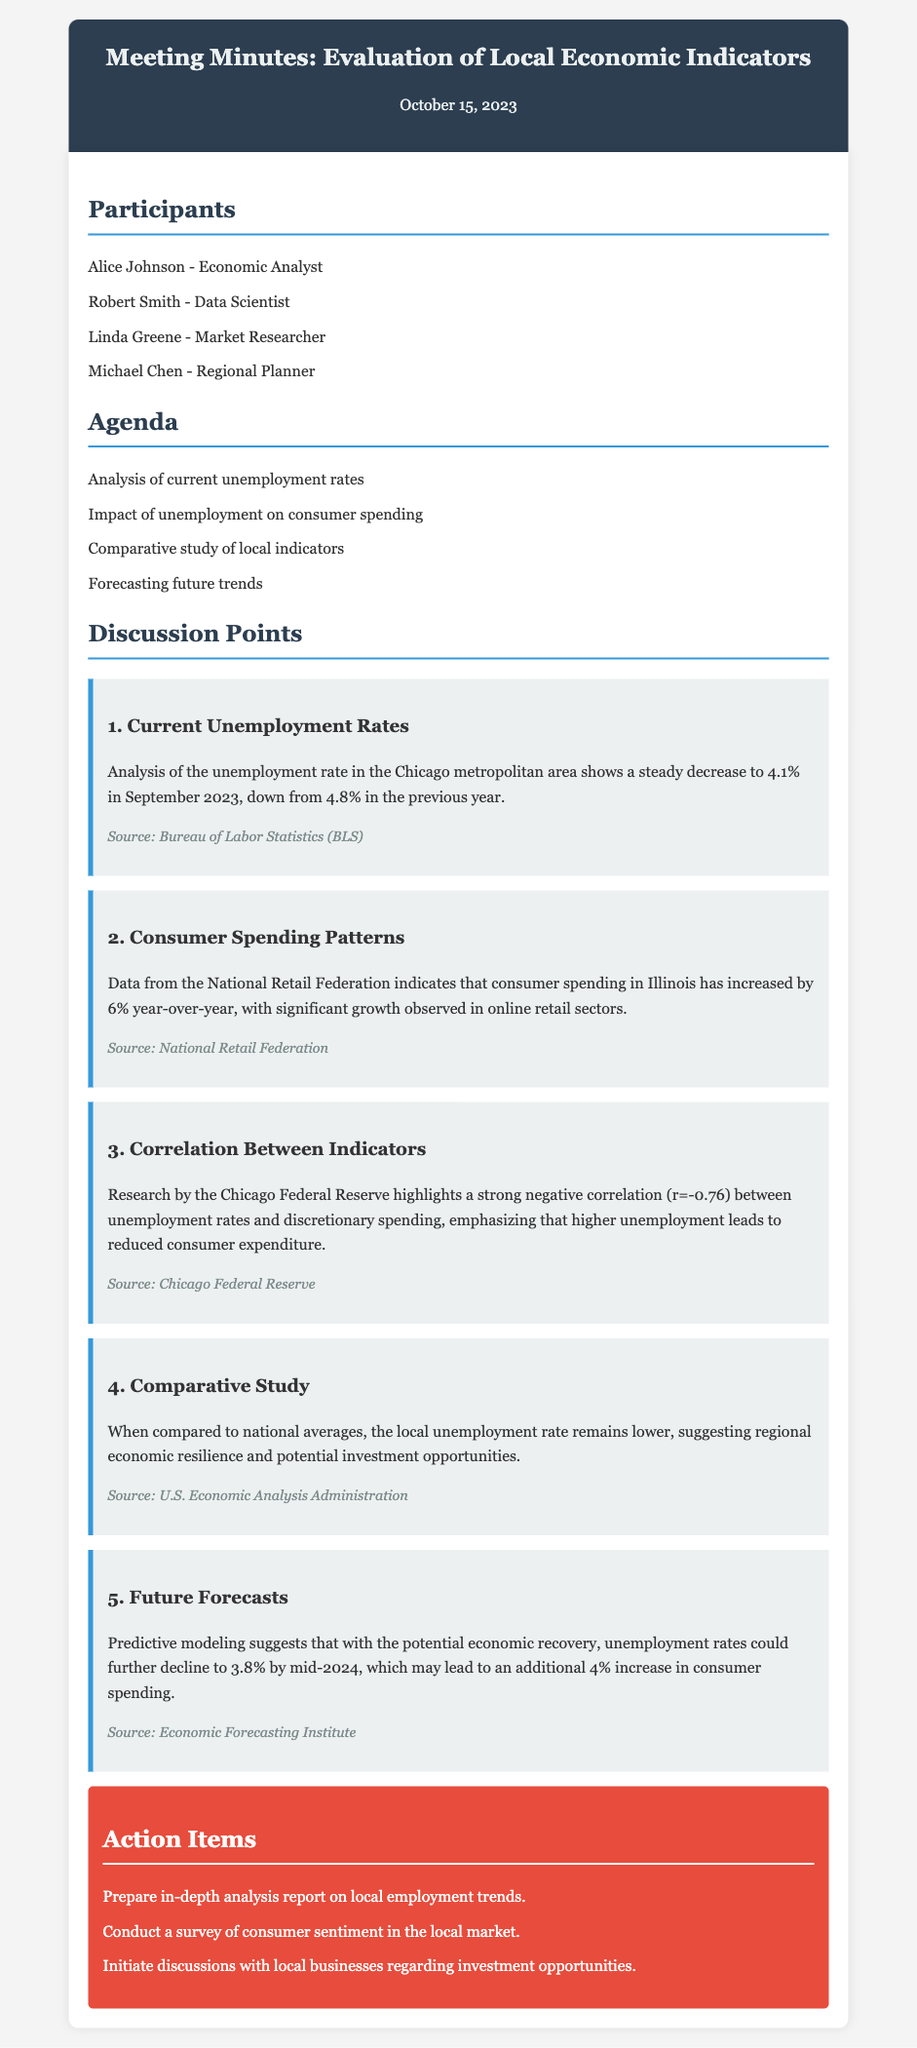What is the unemployment rate in the Chicago metropolitan area as of September 2023? The document states that the unemployment rate in the Chicago metropolitan area is 4.1% in September 2023.
Answer: 4.1% What was the unemployment rate in the previous year? According to the discussion point on current unemployment rates, the previous year's rate was 4.8%.
Answer: 4.8% How much has consumer spending in Illinois increased year-over-year? The document indicates that consumer spending has increased by 6% year-over-year according to the National Retail Federation.
Answer: 6% What is the correlation coefficient between unemployment rates and discretionary spending? The document mentions a strong negative correlation of r=-0.76 between these two factors.
Answer: r=-0.76 What is the predicted unemployment rate by mid-2024? The predictive modeling suggests that unemployment rates could decline to 3.8% by mid-2024.
Answer: 3.8% Who conducted research highlighting the correlation between unemployment and spending? The discussion point notes that this research was conducted by the Chicago Federal Reserve.
Answer: Chicago Federal Reserve What should the in-depth analysis report focus on? The action item specifies to prepare an in-depth analysis report on local employment trends.
Answer: Local employment trends What are participants advised to initiate discussions about? One of the action items suggests initiating discussions with local businesses regarding investment opportunities.
Answer: Investment opportunities Who is the market researcher listed in the participants? The document lists Linda Greene as the market researcher.
Answer: Linda Greene 